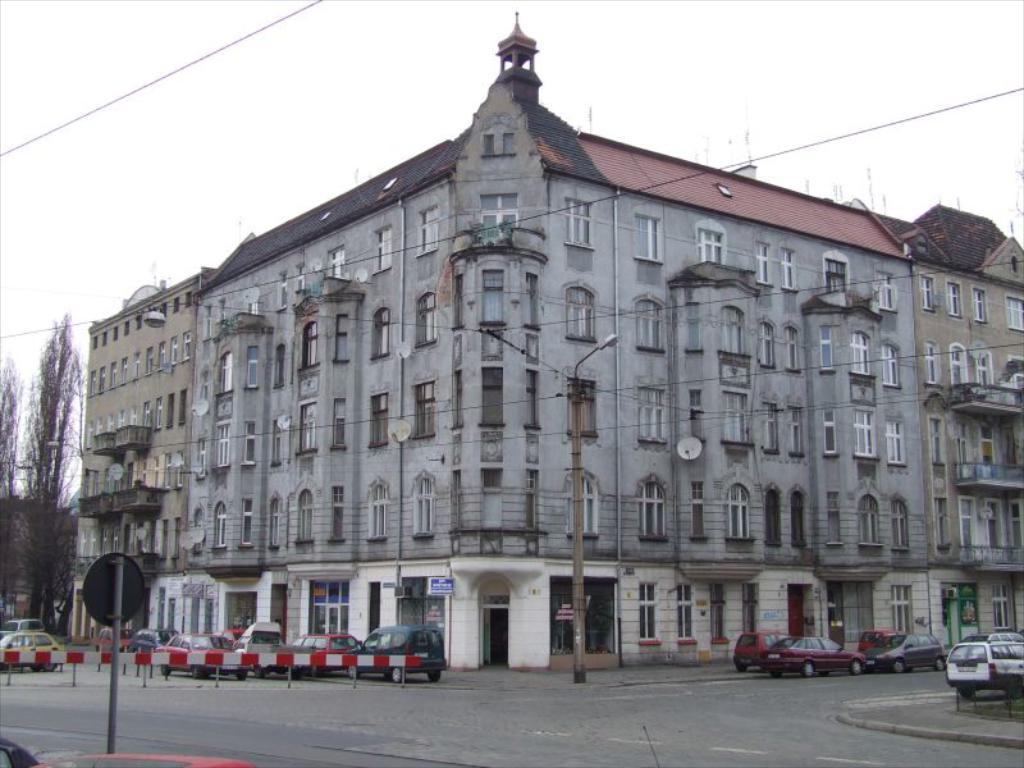Could you give a brief overview of what you see in this image? This picture is clicked outside the city. At the bottom, we see the road. On the right side, we see the cars parked on the road. In the middle, we see a street light and an electric pole. Behind that, we see a building in grey color with a black color roof. Beside that, we see a building. In the left bottom, we see a pole. Behind that, we see the barrier poles and the cars parked on the road. Beside that, we see a board in white and blue color with some text written on it. On the left side, we see the trees. At the top, we see the sky. 